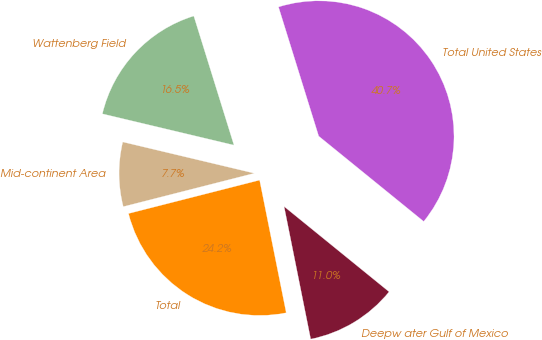Convert chart to OTSL. <chart><loc_0><loc_0><loc_500><loc_500><pie_chart><fcel>Wattenberg Field<fcel>Mid-continent Area<fcel>Total<fcel>Deepw ater Gulf of Mexico<fcel>Total United States<nl><fcel>16.48%<fcel>7.69%<fcel>24.18%<fcel>10.99%<fcel>40.66%<nl></chart> 